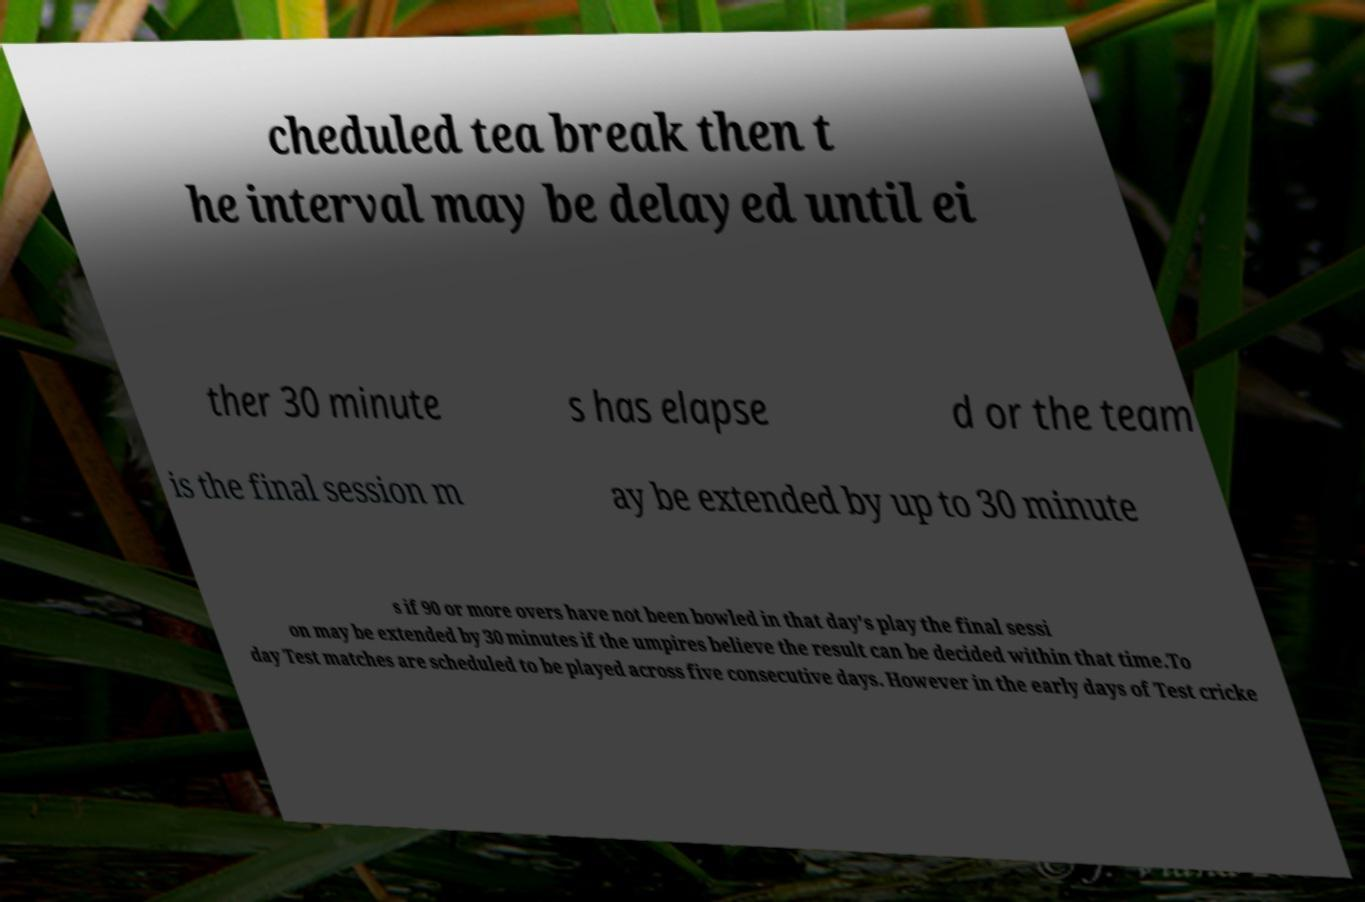Can you accurately transcribe the text from the provided image for me? cheduled tea break then t he interval may be delayed until ei ther 30 minute s has elapse d or the team is the final session m ay be extended by up to 30 minute s if 90 or more overs have not been bowled in that day's play the final sessi on may be extended by 30 minutes if the umpires believe the result can be decided within that time.To day Test matches are scheduled to be played across five consecutive days. However in the early days of Test cricke 